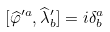Convert formula to latex. <formula><loc_0><loc_0><loc_500><loc_500>[ \widehat { \varphi } ^ { \prime a } , \widehat { \lambda } ^ { \prime } _ { b } ] = i \delta _ { b } ^ { a }</formula> 